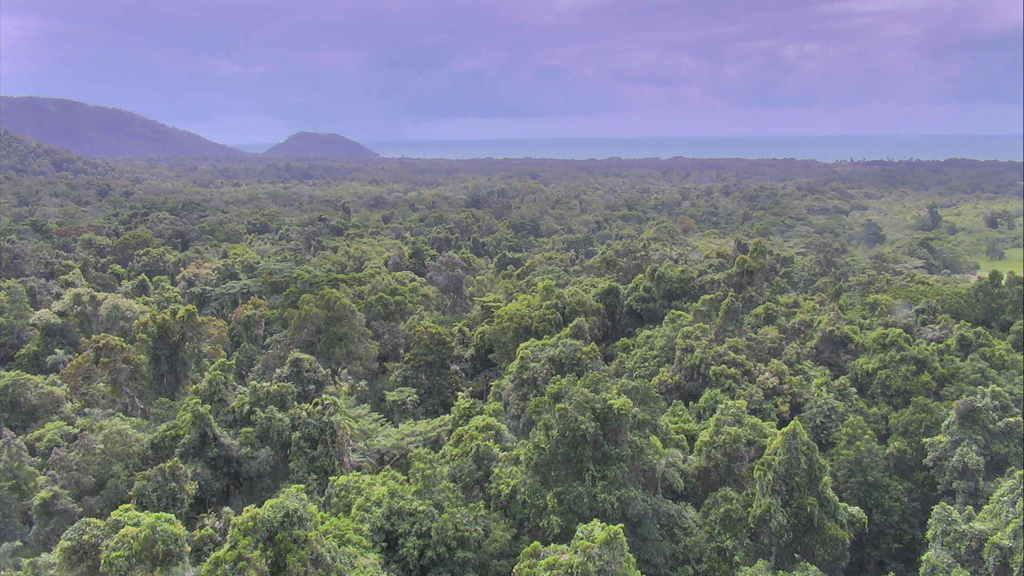What type of vegetation can be seen in the image? There are trees in the image. What natural feature is visible in the background of the image? There are mountains in the background of the image. How does the downtown area affect the acoustics in the image? There is no downtown area mentioned in the image, and therefore no information about its effect on acoustics can be provided. 